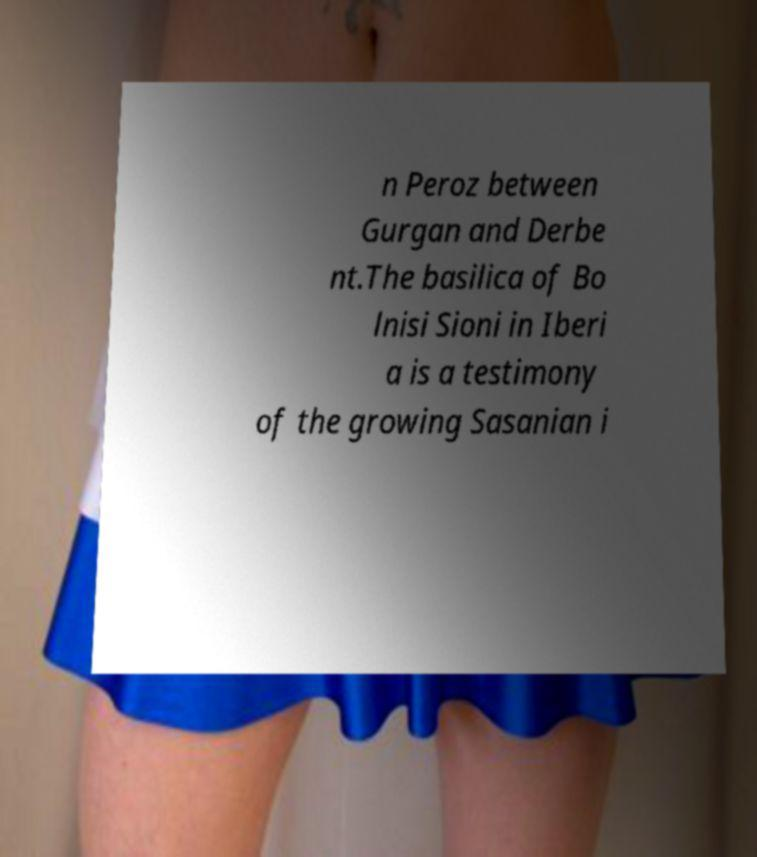For documentation purposes, I need the text within this image transcribed. Could you provide that? n Peroz between Gurgan and Derbe nt.The basilica of Bo lnisi Sioni in Iberi a is a testimony of the growing Sasanian i 